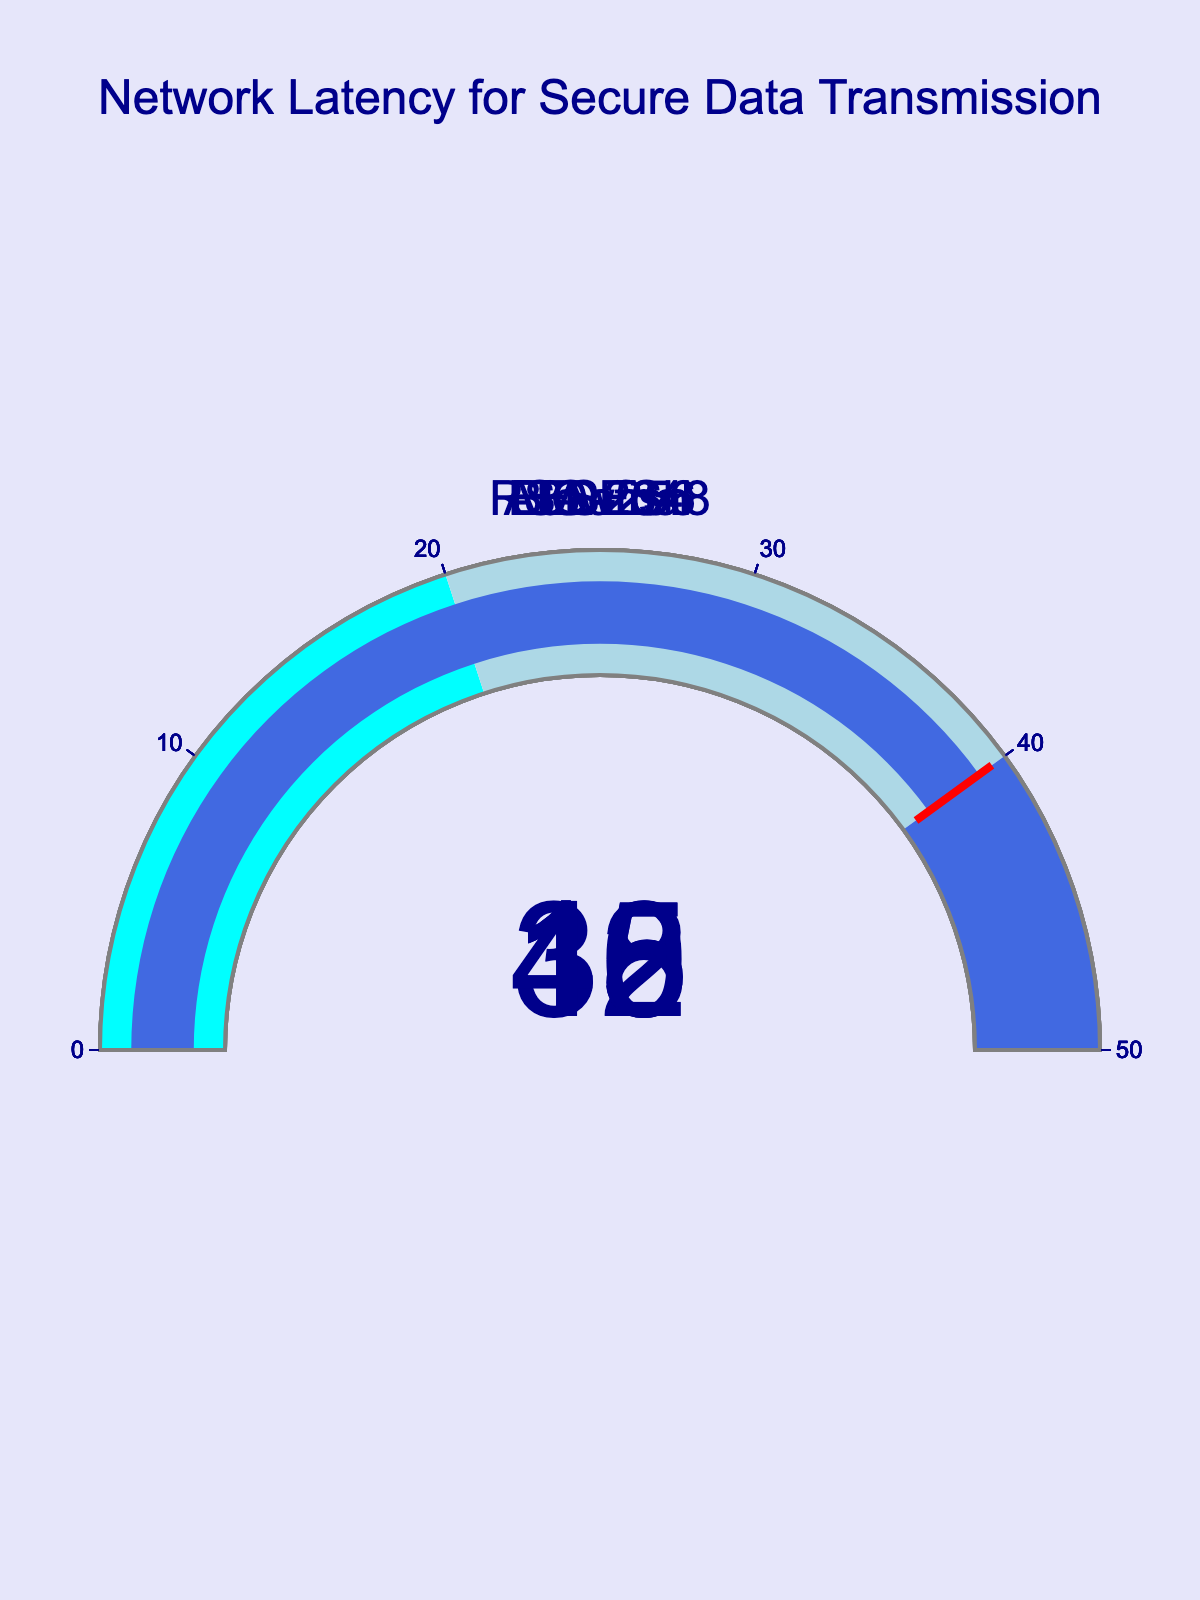What's the title of the figure? The title of a figure is usually displayed prominently at the top. In this case, it reads "Network Latency for Secure Data Transmission".
Answer: Network Latency for Secure Data Transmission How many encryption methods are shown in the figure? Each gauge in the figure corresponds to an encryption method, so counting the number of gauges gives us the number of methods. There are five gauges.
Answer: Five Which encryption method has the highest latency? By comparing the values on each gauge, the highest value represents the highest latency. ElGamal has the highest latency at 40 ms.
Answer: ElGamal What's the sum of latencies for AES-256 and Blowfish? Identify the latency values for each method from the gauges and add them together: AES-256 (12 ms) + Blowfish (15 ms) = 27 ms.
Answer: 27 ms Is there any encryption method with a latency lower than 15 ms? By examining the gauges, we see that AES-256 has a latency of 12 ms and Blowfish has a latency of 15 ms. So, AES-256 is the only one under 15 ms.
Answer: Yes, AES-256 What is the average latency of all encryption methods? Sum the latency values of all methods and divide by the number of methods. (12 + 35 + 18 + 15 + 40) / 5 = 24 ms.
Answer: 24 ms Which encryption method appears closest to the threshold value marked on the gauge charts? The threshold in the gauges is marked at 40 ms. ElGamal has a latency exactly at this threshold value, making it closest.
Answer: ElGamal How much higher is RSA-2048's latency compared to AES-256? Subtract AES-256's latency from RSA-2048's: 35 ms - 12 ms = 23 ms.
Answer: 23 ms What is the color coding of the ranges between 20 and 40 ms in the gauge charts? Observing the gauge charts, the color for the range between 20 and 40 ms is light blue.
Answer: Light blue 